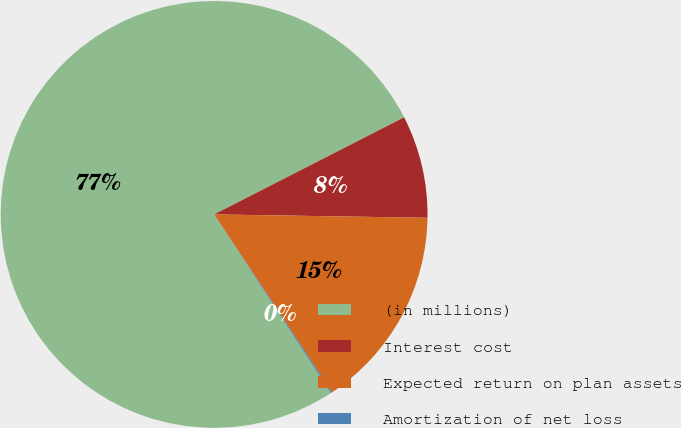Convert chart. <chart><loc_0><loc_0><loc_500><loc_500><pie_chart><fcel>(in millions)<fcel>Interest cost<fcel>Expected return on plan assets<fcel>Amortization of net loss<nl><fcel>76.69%<fcel>7.77%<fcel>15.43%<fcel>0.11%<nl></chart> 